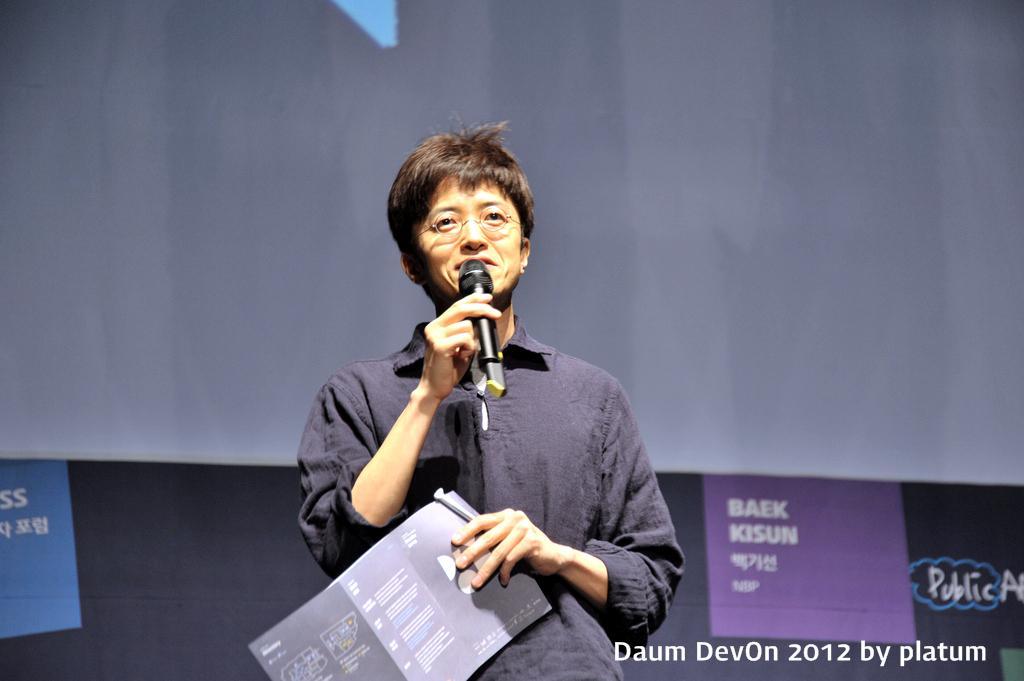Describe this image in one or two sentences. In the center of the image, we can see a person wearing glasses and holding papers and a mic. In the background, there are posters with some text and there is a white sheet. At the bottom, there is some text. 